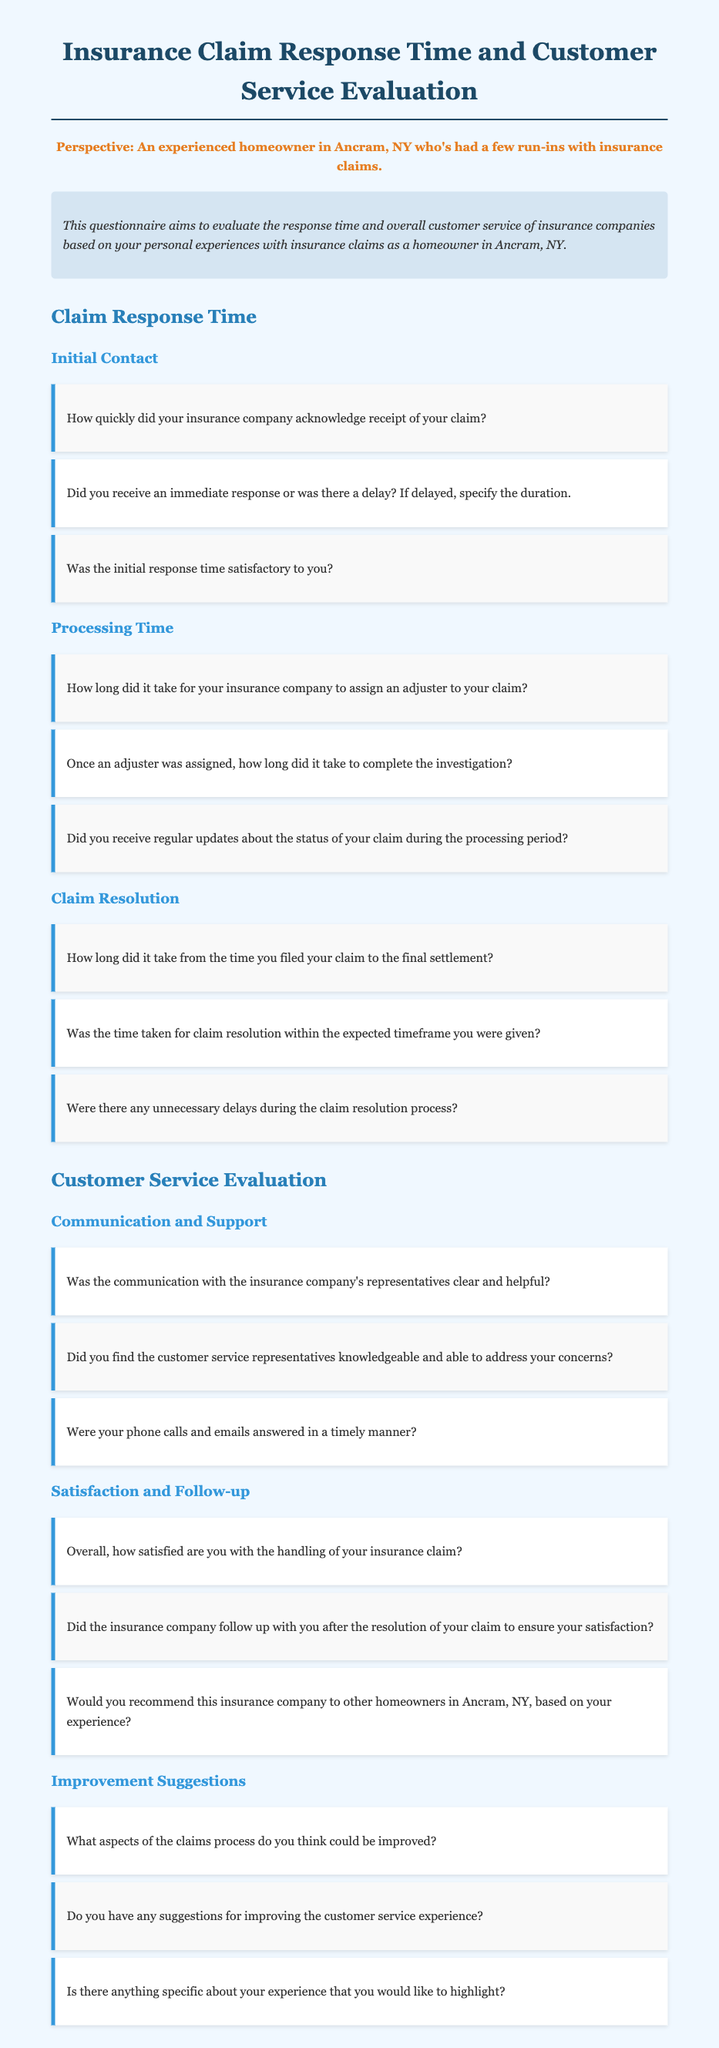What is the title of the document? The title is presented at the beginning of the document in large text.
Answer: Insurance Claim Response Time and Customer Service Evaluation 